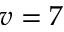<formula> <loc_0><loc_0><loc_500><loc_500>v = 7</formula> 